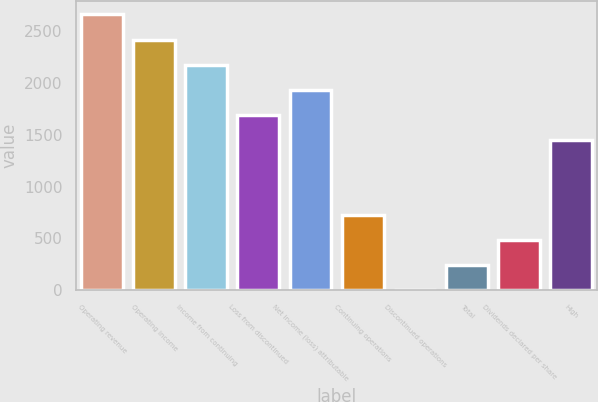Convert chart. <chart><loc_0><loc_0><loc_500><loc_500><bar_chart><fcel>Operating revenue<fcel>Operating income<fcel>Income from continuing<fcel>Loss from discontinued<fcel>Net income (loss) attributable<fcel>Continuing operations<fcel>Discontinued operations<fcel>Total<fcel>Dividends declared per share<fcel>High<nl><fcel>2656.43<fcel>2414.96<fcel>2173.49<fcel>1690.55<fcel>1932.02<fcel>724.67<fcel>0.26<fcel>241.73<fcel>483.2<fcel>1449.08<nl></chart> 